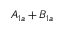Convert formula to latex. <formula><loc_0><loc_0><loc_500><loc_500>A _ { 1 a } + B _ { 1 a }</formula> 